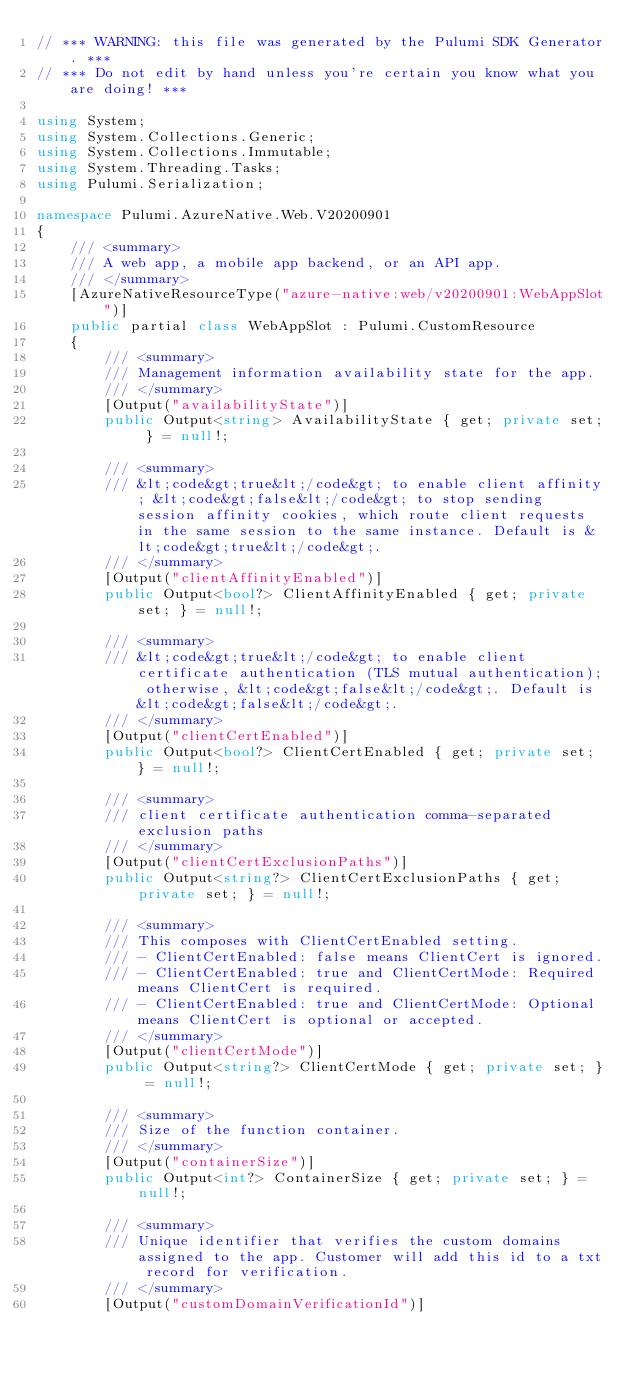Convert code to text. <code><loc_0><loc_0><loc_500><loc_500><_C#_>// *** WARNING: this file was generated by the Pulumi SDK Generator. ***
// *** Do not edit by hand unless you're certain you know what you are doing! ***

using System;
using System.Collections.Generic;
using System.Collections.Immutable;
using System.Threading.Tasks;
using Pulumi.Serialization;

namespace Pulumi.AzureNative.Web.V20200901
{
    /// <summary>
    /// A web app, a mobile app backend, or an API app.
    /// </summary>
    [AzureNativeResourceType("azure-native:web/v20200901:WebAppSlot")]
    public partial class WebAppSlot : Pulumi.CustomResource
    {
        /// <summary>
        /// Management information availability state for the app.
        /// </summary>
        [Output("availabilityState")]
        public Output<string> AvailabilityState { get; private set; } = null!;

        /// <summary>
        /// &lt;code&gt;true&lt;/code&gt; to enable client affinity; &lt;code&gt;false&lt;/code&gt; to stop sending session affinity cookies, which route client requests in the same session to the same instance. Default is &lt;code&gt;true&lt;/code&gt;.
        /// </summary>
        [Output("clientAffinityEnabled")]
        public Output<bool?> ClientAffinityEnabled { get; private set; } = null!;

        /// <summary>
        /// &lt;code&gt;true&lt;/code&gt; to enable client certificate authentication (TLS mutual authentication); otherwise, &lt;code&gt;false&lt;/code&gt;. Default is &lt;code&gt;false&lt;/code&gt;.
        /// </summary>
        [Output("clientCertEnabled")]
        public Output<bool?> ClientCertEnabled { get; private set; } = null!;

        /// <summary>
        /// client certificate authentication comma-separated exclusion paths
        /// </summary>
        [Output("clientCertExclusionPaths")]
        public Output<string?> ClientCertExclusionPaths { get; private set; } = null!;

        /// <summary>
        /// This composes with ClientCertEnabled setting.
        /// - ClientCertEnabled: false means ClientCert is ignored.
        /// - ClientCertEnabled: true and ClientCertMode: Required means ClientCert is required.
        /// - ClientCertEnabled: true and ClientCertMode: Optional means ClientCert is optional or accepted.
        /// </summary>
        [Output("clientCertMode")]
        public Output<string?> ClientCertMode { get; private set; } = null!;

        /// <summary>
        /// Size of the function container.
        /// </summary>
        [Output("containerSize")]
        public Output<int?> ContainerSize { get; private set; } = null!;

        /// <summary>
        /// Unique identifier that verifies the custom domains assigned to the app. Customer will add this id to a txt record for verification.
        /// </summary>
        [Output("customDomainVerificationId")]</code> 